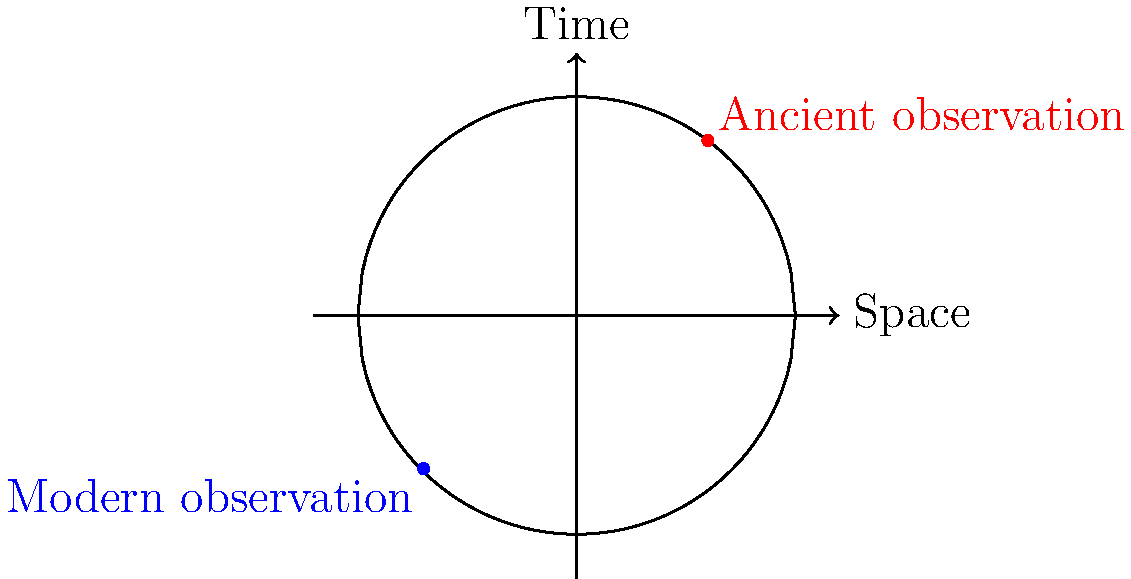In the context of ancient astronomical observations, how does the curvature of space-time affect the interpretation of historical data compared to modern observations? Consider the diagram showing the space-time curvature and two observation points. To understand the effect of space-time curvature on ancient astronomical observations:

1. Space-time curvature: The diagram shows a curved space-time represented by a circle, illustrating Einstein's theory of general relativity.

2. Ancient observation: The red dot represents an ancient astronomical observation, located in a different part of the curved space-time than the modern observation (blue dot).

3. Light path: Light travels along geodesics in curved space-time, which are not necessarily straight lines in this representation.

4. Time dilation: The curvature affects the passage of time differently at various points in space-time. This means that time might have flowed differently for ancient observers compared to modern ones.

5. Gravitational lensing: The curvature of space-time can bend light, potentially affecting how ancient astronomers perceived celestial objects.

6. Redshift: Light traveling through curved space-time experiences gravitational redshift, which could impact the interpretation of spectral data from ancient observations.

7. Precession: The curvature of space-time causes the precession of orbits, which accumulates over time and might be more noticeable in ancient data.

8. Historical interpretation: Archaeologists must account for these relativistic effects when interpreting ancient astronomical records, as the observed phenomena might appear different due to the curvature of space-time.

9. Calibration: Modern observations (blue dot) can be used to calibrate and correct ancient data, accounting for the differences in space-time curvature between the two epochs.

The key is that the curvature of space-time introduces systematic differences between ancient and modern astronomical observations, which must be considered in archaeological interpretations.
Answer: Space-time curvature introduces relativistic effects (time dilation, gravitational lensing, redshift, and precession) that systematically alter ancient astronomical observations compared to modern ones, requiring careful calibration and interpretation in archaeological studies. 